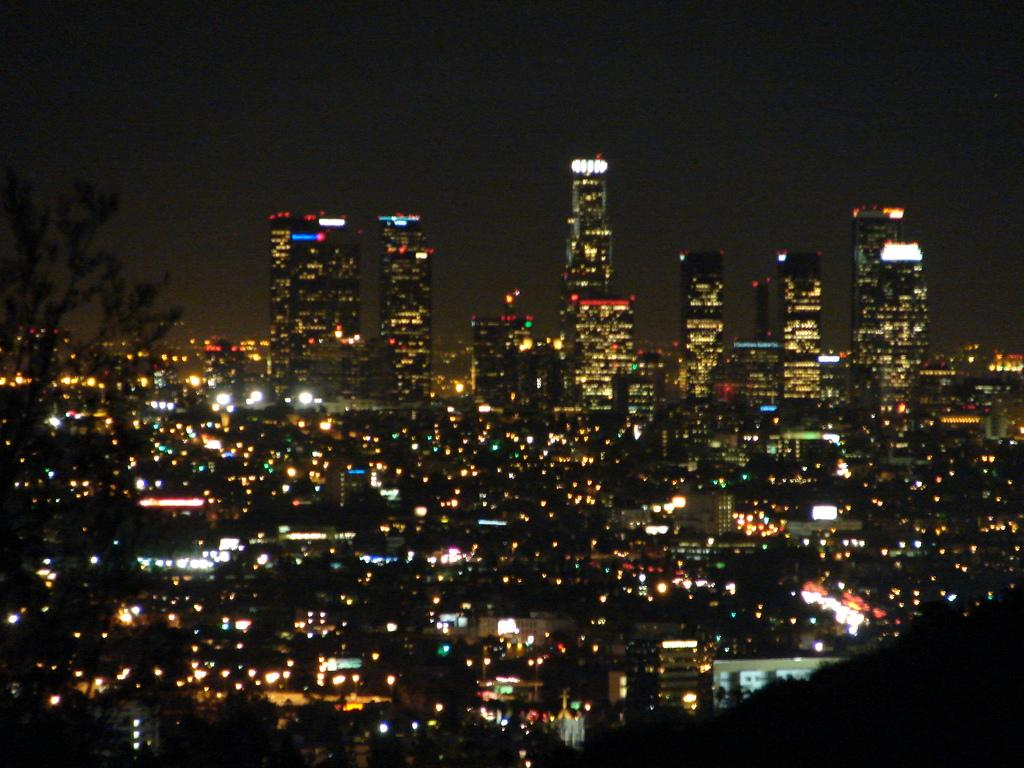What time of day was the image taken? The image was taken at nighttime. What can be seen in the center of the image? There are many buildings in the center of the image. What type of vegetation is on the left side of the image? There is a tree on the left side of the image. What type of vessel is floating in the image? There is no vessel present in the image; it only features buildings, a tree, and the nighttime setting. 